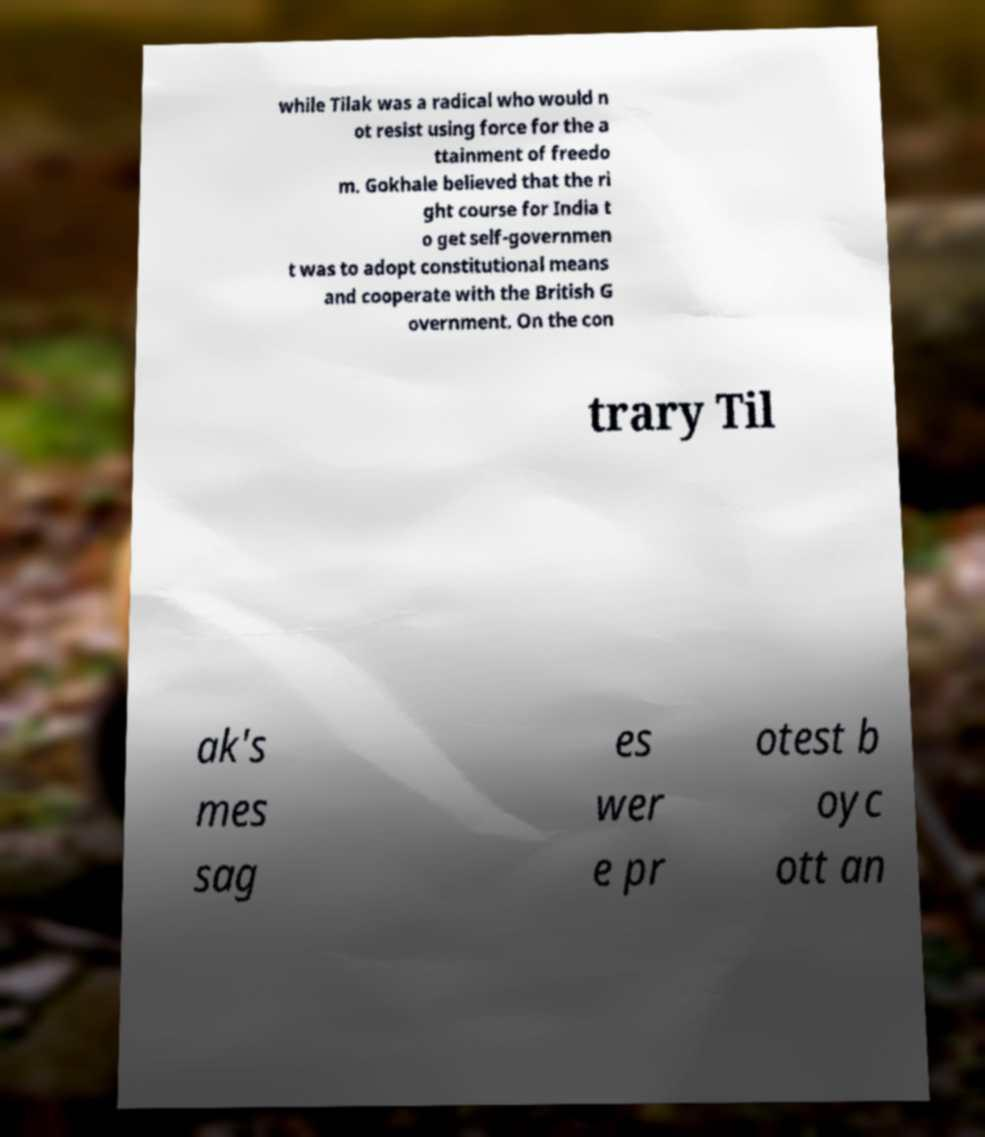What messages or text are displayed in this image? I need them in a readable, typed format. while Tilak was a radical who would n ot resist using force for the a ttainment of freedo m. Gokhale believed that the ri ght course for India t o get self-governmen t was to adopt constitutional means and cooperate with the British G overnment. On the con trary Til ak's mes sag es wer e pr otest b oyc ott an 